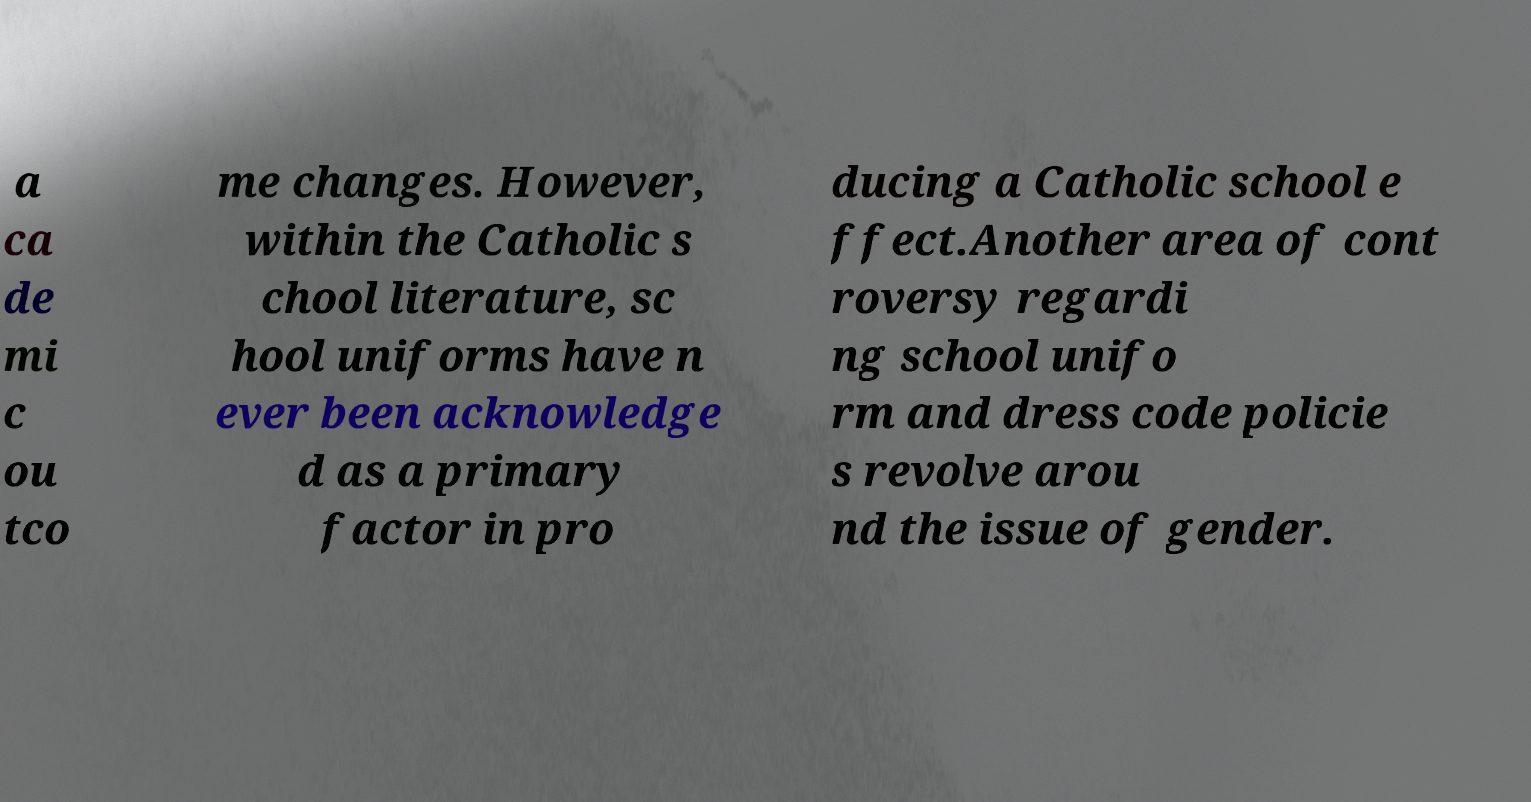Could you assist in decoding the text presented in this image and type it out clearly? a ca de mi c ou tco me changes. However, within the Catholic s chool literature, sc hool uniforms have n ever been acknowledge d as a primary factor in pro ducing a Catholic school e ffect.Another area of cont roversy regardi ng school unifo rm and dress code policie s revolve arou nd the issue of gender. 